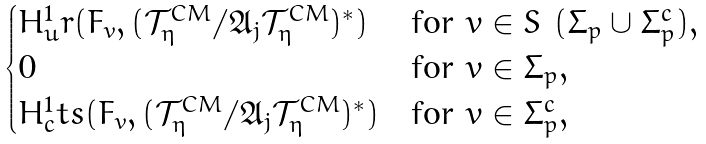<formula> <loc_0><loc_0><loc_500><loc_500>\begin{cases} H ^ { 1 } _ { u } r ( F _ { v } , ( \mathcal { T } ^ { C M } _ { \eta } / \mathfrak { A } _ { j } \mathcal { T } ^ { C M } _ { \eta } ) ^ { * } ) & \text {for $v \in S\ (\Sigma_{p}\cup \Sigma_{p}^{c})$} , \\ 0 & \text {for $v\in \Sigma_{p}$} , \\ H ^ { 1 } _ { c } t s ( F _ { v } , ( \mathcal { T } ^ { C M } _ { \eta } / \mathfrak { A } _ { j } \mathcal { T } ^ { C M } _ { \eta } ) ^ { * } ) & \text {for $v\in \Sigma_{p}^{c}$} , \end{cases}</formula> 